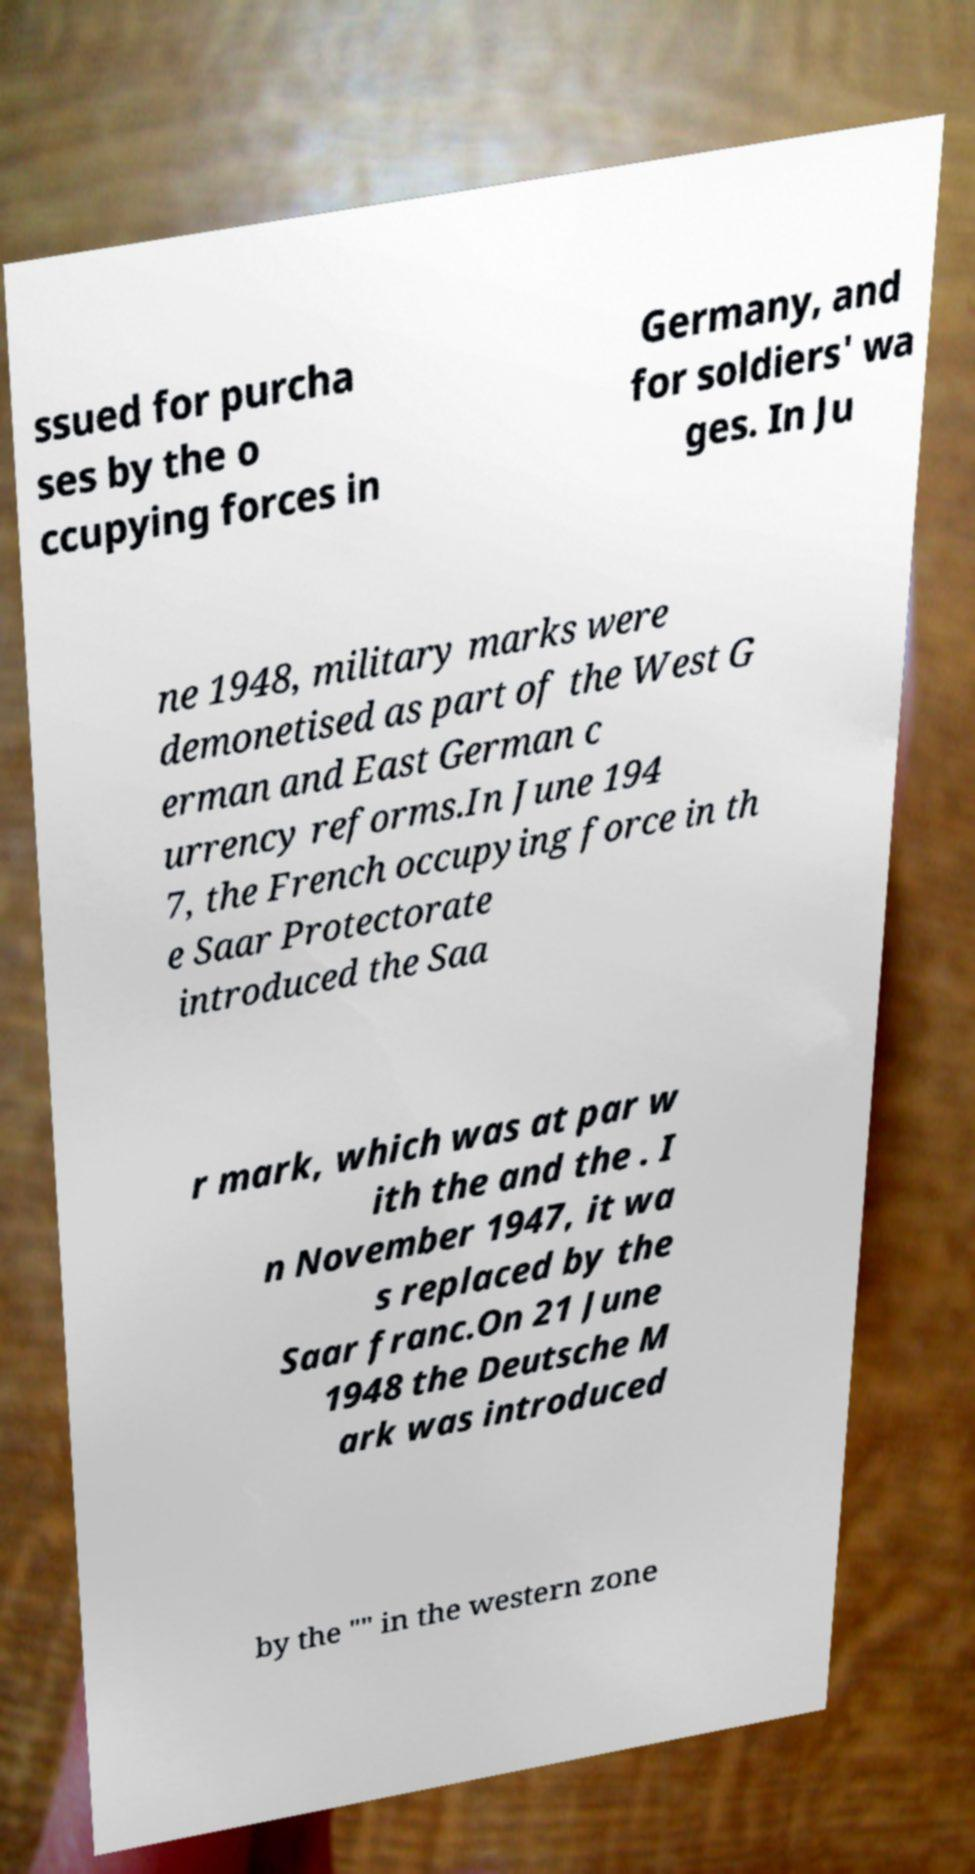For documentation purposes, I need the text within this image transcribed. Could you provide that? ssued for purcha ses by the o ccupying forces in Germany, and for soldiers' wa ges. In Ju ne 1948, military marks were demonetised as part of the West G erman and East German c urrency reforms.In June 194 7, the French occupying force in th e Saar Protectorate introduced the Saa r mark, which was at par w ith the and the . I n November 1947, it wa s replaced by the Saar franc.On 21 June 1948 the Deutsche M ark was introduced by the "" in the western zone 